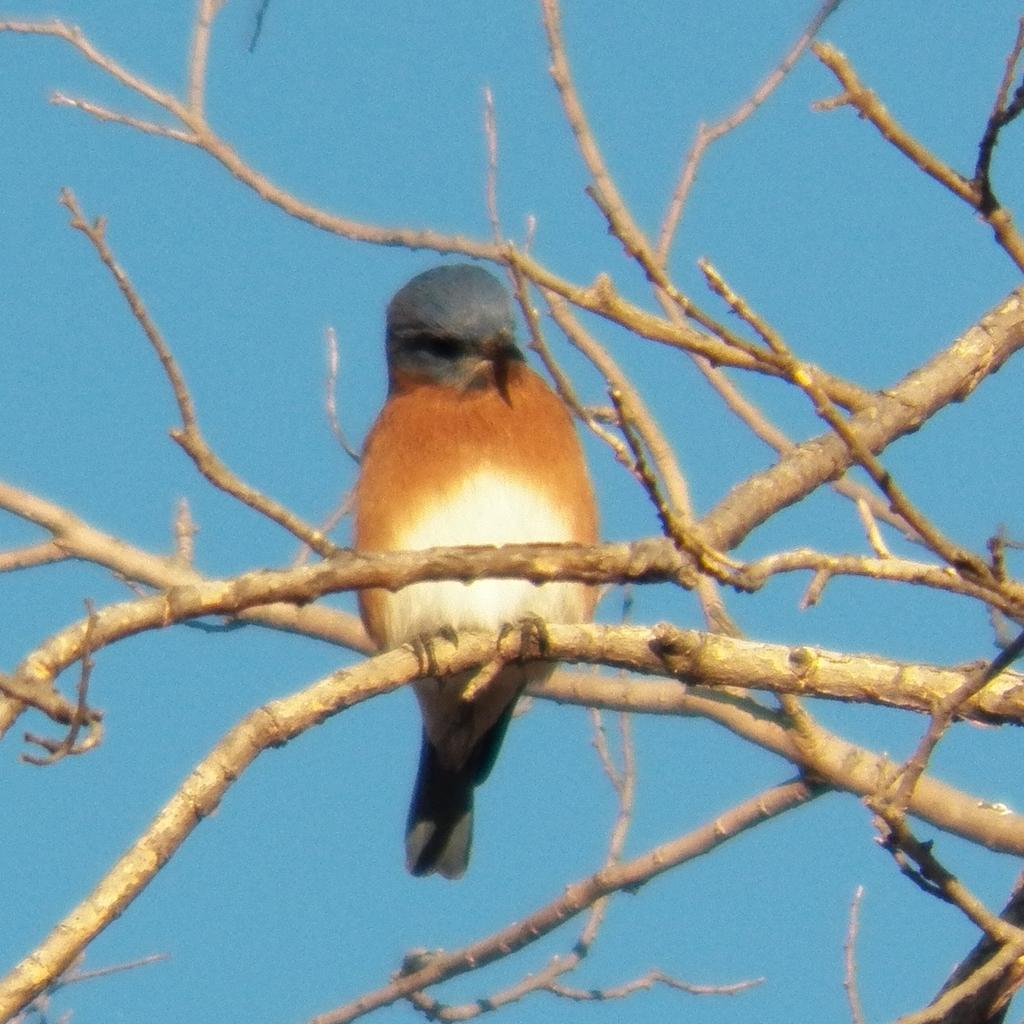What type of animal can be seen in the image? There is a bird visible in the image. What is the bird standing on? The bird is on sticks. What can be seen in the background of the image? The sky is visible in the background of the image. How many laborers are working in the image? There are no laborers present in the image; it features a bird on sticks with the sky visible in the background. How many drops of water can be seen falling from the bird in the image? There are no drops of water visible in the image; it only shows a bird on sticks with the sky in the background. 